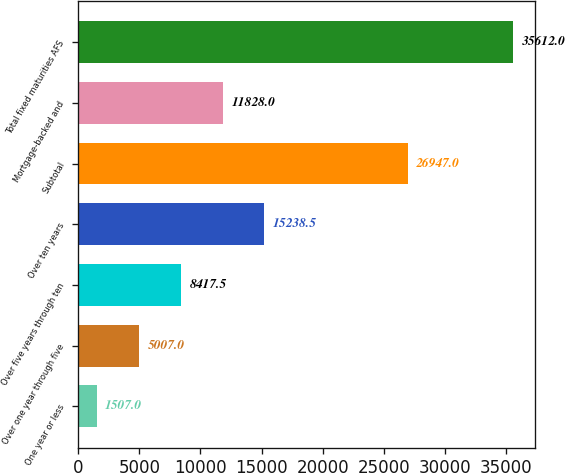Convert chart. <chart><loc_0><loc_0><loc_500><loc_500><bar_chart><fcel>One year or less<fcel>Over one year through five<fcel>Over five years through ten<fcel>Over ten years<fcel>Subtotal<fcel>Mortgage-backed and<fcel>Total fixed maturities AFS<nl><fcel>1507<fcel>5007<fcel>8417.5<fcel>15238.5<fcel>26947<fcel>11828<fcel>35612<nl></chart> 